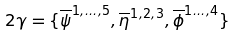Convert formula to latex. <formula><loc_0><loc_0><loc_500><loc_500>2 \gamma = \{ { \overline { \psi } } ^ { 1 , \dots , 5 } , { \overline { \eta } } ^ { 1 , 2 , 3 } , { \overline { \phi } } ^ { 1 \dots , 4 } \}</formula> 